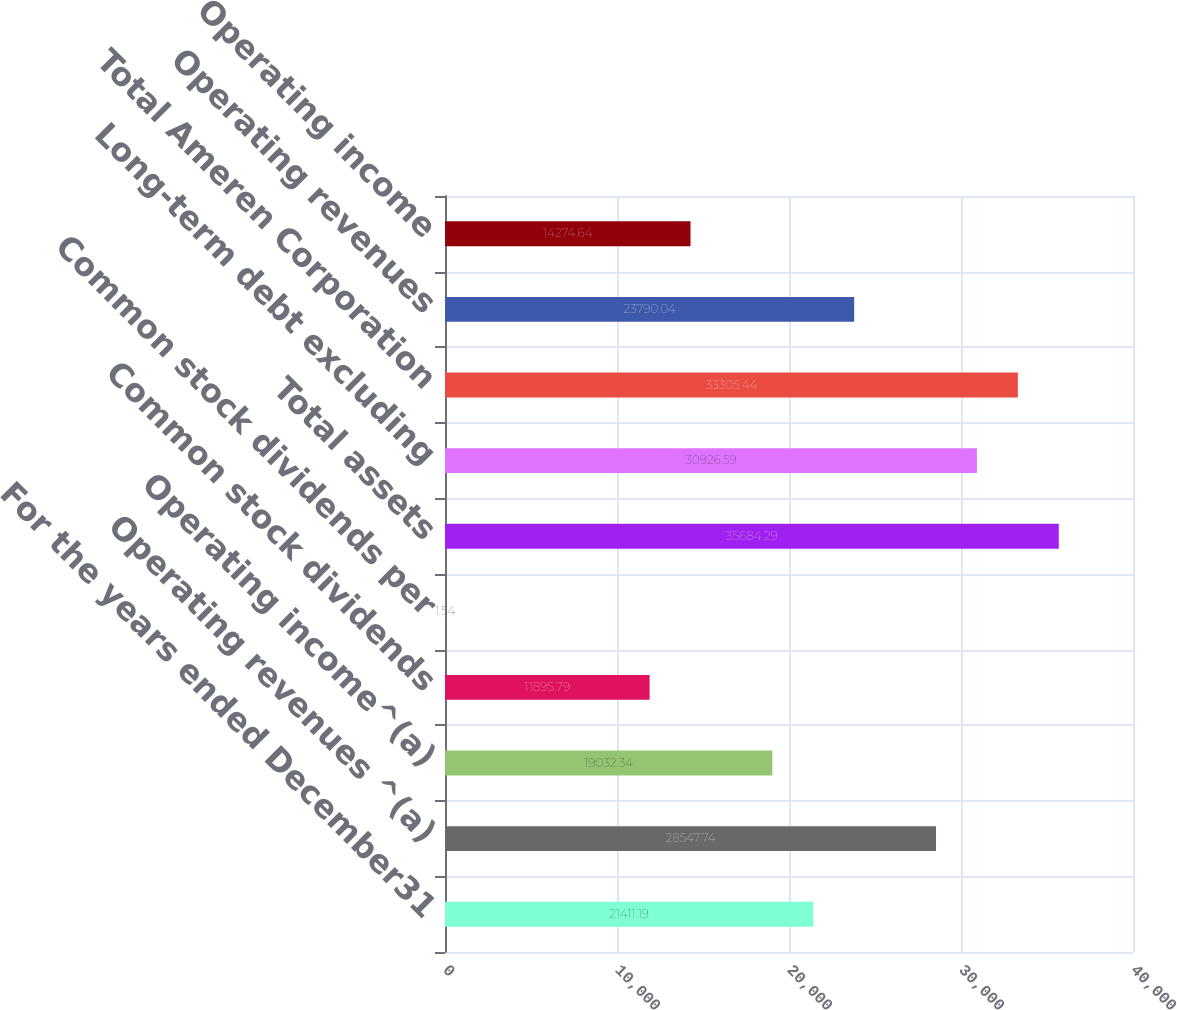Convert chart to OTSL. <chart><loc_0><loc_0><loc_500><loc_500><bar_chart><fcel>For the years ended December31<fcel>Operating revenues ^(a)<fcel>Operating income^(a)<fcel>Common stock dividends<fcel>Common stock dividends per<fcel>Total assets<fcel>Long-term debt excluding<fcel>Total Ameren Corporation<fcel>Operating revenues<fcel>Operating income<nl><fcel>21411.2<fcel>28547.7<fcel>19032.3<fcel>11895.8<fcel>1.54<fcel>35684.3<fcel>30926.6<fcel>33305.4<fcel>23790<fcel>14274.6<nl></chart> 